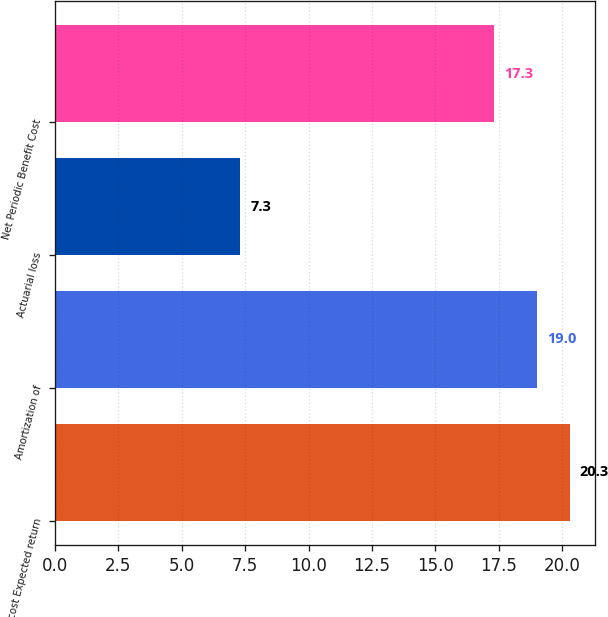Convert chart to OTSL. <chart><loc_0><loc_0><loc_500><loc_500><bar_chart><fcel>Interest cost Expected return<fcel>Amortization of<fcel>Actuarial loss<fcel>Net Periodic Benefit Cost<nl><fcel>20.3<fcel>19<fcel>7.3<fcel>17.3<nl></chart> 